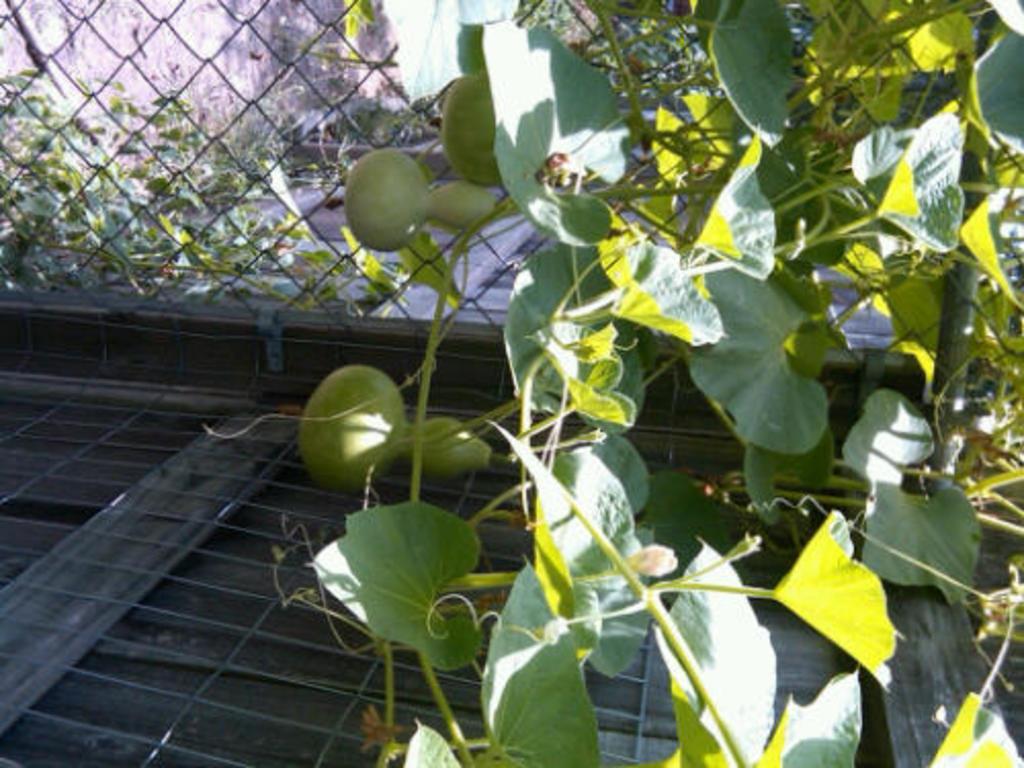How would you summarize this image in a sentence or two? On the right side of the image there is a creeper with leaves and fruits. On the left of the image there is a fencing. Behind the fencing there are leaves. 